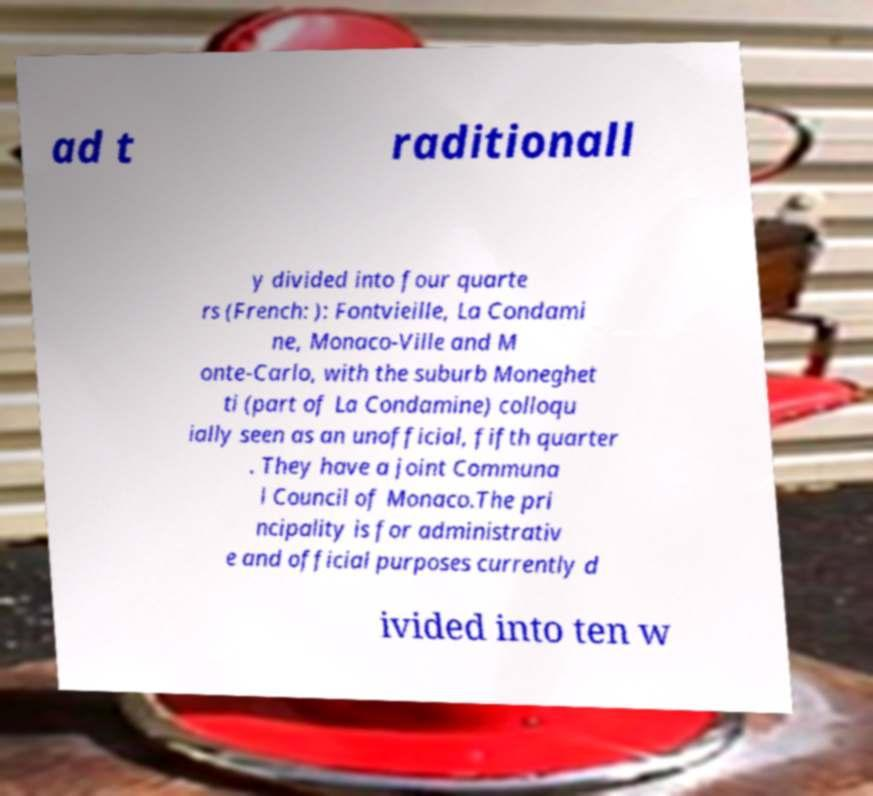Please read and relay the text visible in this image. What does it say? ad t raditionall y divided into four quarte rs (French: ): Fontvieille, La Condami ne, Monaco-Ville and M onte-Carlo, with the suburb Moneghet ti (part of La Condamine) colloqu ially seen as an unofficial, fifth quarter . They have a joint Communa l Council of Monaco.The pri ncipality is for administrativ e and official purposes currently d ivided into ten w 